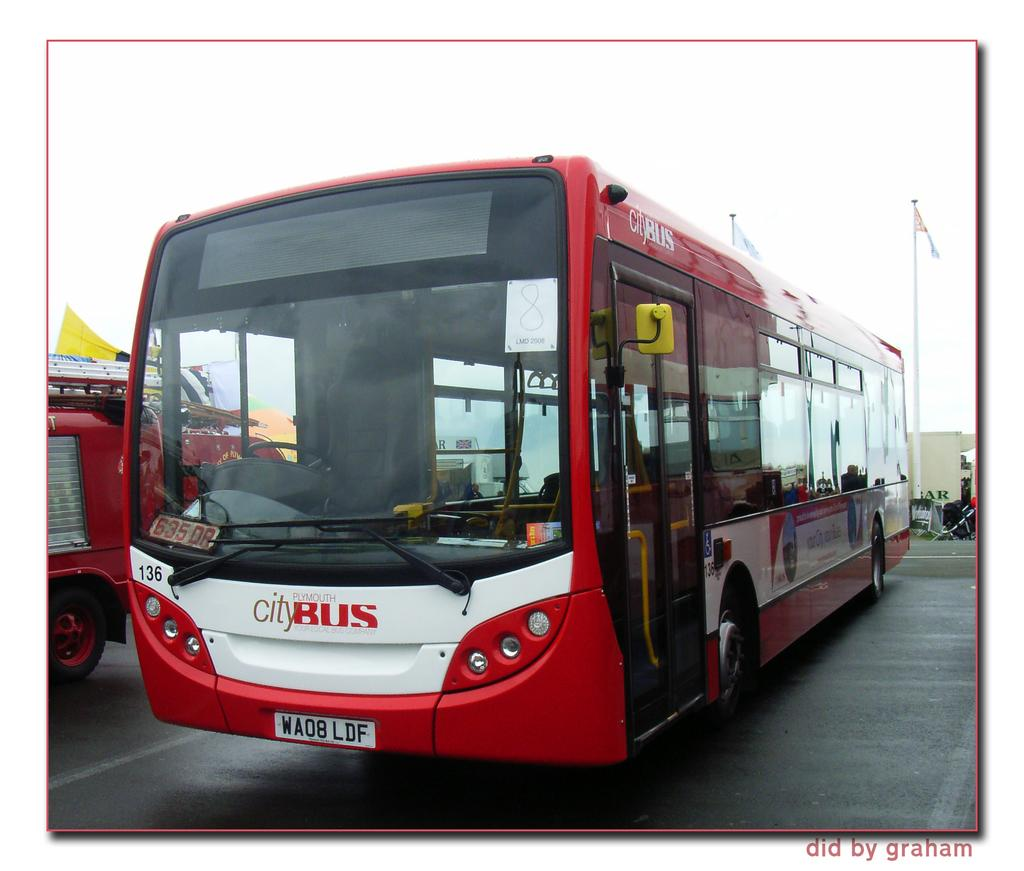<image>
Summarize the visual content of the image. A red City bus is parked in a parking lot. 